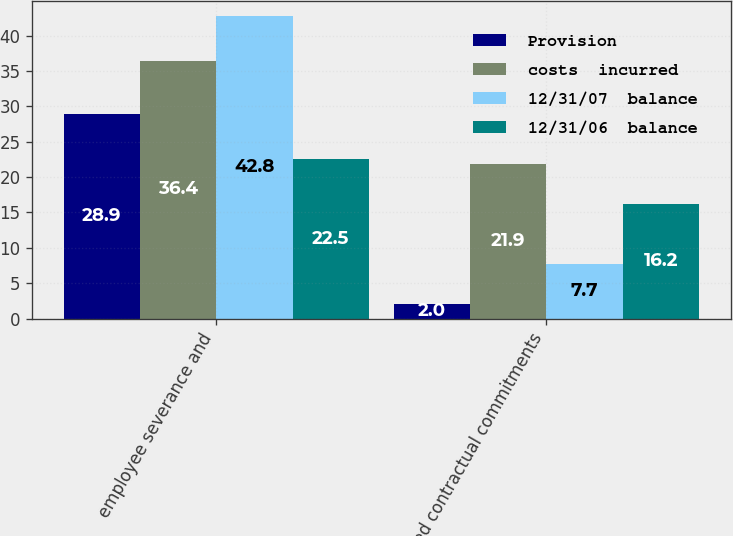Convert chart. <chart><loc_0><loc_0><loc_500><loc_500><stacked_bar_chart><ecel><fcel>employee severance and<fcel>exited contractual commitments<nl><fcel>Provision<fcel>28.9<fcel>2<nl><fcel>costs  incurred<fcel>36.4<fcel>21.9<nl><fcel>12/31/07  balance<fcel>42.8<fcel>7.7<nl><fcel>12/31/06  balance<fcel>22.5<fcel>16.2<nl></chart> 